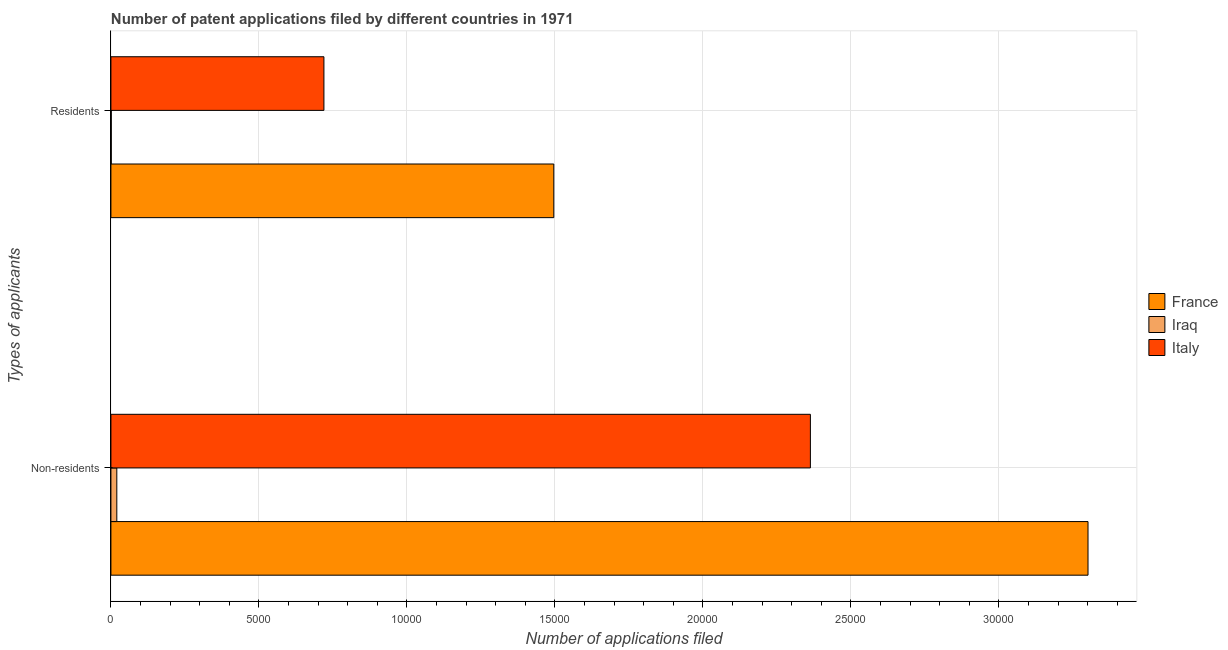What is the label of the 1st group of bars from the top?
Give a very brief answer. Residents. What is the number of patent applications by non residents in Iraq?
Provide a short and direct response. 199. Across all countries, what is the maximum number of patent applications by non residents?
Provide a succinct answer. 3.30e+04. Across all countries, what is the minimum number of patent applications by non residents?
Keep it short and to the point. 199. In which country was the number of patent applications by residents maximum?
Ensure brevity in your answer.  France. In which country was the number of patent applications by residents minimum?
Provide a short and direct response. Iraq. What is the total number of patent applications by non residents in the graph?
Provide a succinct answer. 5.68e+04. What is the difference between the number of patent applications by residents in Iraq and that in France?
Provide a short and direct response. -1.50e+04. What is the difference between the number of patent applications by residents in Italy and the number of patent applications by non residents in France?
Make the answer very short. -2.58e+04. What is the average number of patent applications by non residents per country?
Your response must be concise. 1.89e+04. What is the difference between the number of patent applications by non residents and number of patent applications by residents in Italy?
Make the answer very short. 1.64e+04. What is the ratio of the number of patent applications by non residents in Iraq to that in Italy?
Ensure brevity in your answer.  0.01. In how many countries, is the number of patent applications by residents greater than the average number of patent applications by residents taken over all countries?
Give a very brief answer. 1. What does the 2nd bar from the top in Residents represents?
Your answer should be compact. Iraq. Are all the bars in the graph horizontal?
Offer a terse response. Yes. How many countries are there in the graph?
Ensure brevity in your answer.  3. What is the difference between two consecutive major ticks on the X-axis?
Your response must be concise. 5000. Are the values on the major ticks of X-axis written in scientific E-notation?
Offer a very short reply. No. Does the graph contain any zero values?
Give a very brief answer. No. Does the graph contain grids?
Provide a short and direct response. Yes. How many legend labels are there?
Offer a very short reply. 3. What is the title of the graph?
Your answer should be compact. Number of patent applications filed by different countries in 1971. Does "Ethiopia" appear as one of the legend labels in the graph?
Your answer should be compact. No. What is the label or title of the X-axis?
Your answer should be compact. Number of applications filed. What is the label or title of the Y-axis?
Keep it short and to the point. Types of applicants. What is the Number of applications filed in France in Non-residents?
Offer a very short reply. 3.30e+04. What is the Number of applications filed of Iraq in Non-residents?
Offer a terse response. 199. What is the Number of applications filed of Italy in Non-residents?
Your answer should be very brief. 2.36e+04. What is the Number of applications filed in France in Residents?
Offer a terse response. 1.50e+04. What is the Number of applications filed of Italy in Residents?
Your response must be concise. 7196. Across all Types of applicants, what is the maximum Number of applications filed in France?
Your answer should be very brief. 3.30e+04. Across all Types of applicants, what is the maximum Number of applications filed in Iraq?
Provide a short and direct response. 199. Across all Types of applicants, what is the maximum Number of applications filed of Italy?
Make the answer very short. 2.36e+04. Across all Types of applicants, what is the minimum Number of applications filed in France?
Keep it short and to the point. 1.50e+04. Across all Types of applicants, what is the minimum Number of applications filed of Iraq?
Give a very brief answer. 12. Across all Types of applicants, what is the minimum Number of applications filed in Italy?
Make the answer very short. 7196. What is the total Number of applications filed in France in the graph?
Your answer should be compact. 4.80e+04. What is the total Number of applications filed of Iraq in the graph?
Your answer should be very brief. 211. What is the total Number of applications filed of Italy in the graph?
Provide a short and direct response. 3.08e+04. What is the difference between the Number of applications filed of France in Non-residents and that in Residents?
Make the answer very short. 1.80e+04. What is the difference between the Number of applications filed of Iraq in Non-residents and that in Residents?
Provide a succinct answer. 187. What is the difference between the Number of applications filed of Italy in Non-residents and that in Residents?
Provide a succinct answer. 1.64e+04. What is the difference between the Number of applications filed in France in Non-residents and the Number of applications filed in Iraq in Residents?
Your response must be concise. 3.30e+04. What is the difference between the Number of applications filed in France in Non-residents and the Number of applications filed in Italy in Residents?
Your answer should be very brief. 2.58e+04. What is the difference between the Number of applications filed of Iraq in Non-residents and the Number of applications filed of Italy in Residents?
Your answer should be very brief. -6997. What is the average Number of applications filed in France per Types of applicants?
Provide a short and direct response. 2.40e+04. What is the average Number of applications filed of Iraq per Types of applicants?
Provide a short and direct response. 105.5. What is the average Number of applications filed in Italy per Types of applicants?
Provide a short and direct response. 1.54e+04. What is the difference between the Number of applications filed in France and Number of applications filed in Iraq in Non-residents?
Offer a very short reply. 3.28e+04. What is the difference between the Number of applications filed of France and Number of applications filed of Italy in Non-residents?
Your answer should be very brief. 9379. What is the difference between the Number of applications filed in Iraq and Number of applications filed in Italy in Non-residents?
Offer a very short reply. -2.34e+04. What is the difference between the Number of applications filed in France and Number of applications filed in Iraq in Residents?
Your response must be concise. 1.50e+04. What is the difference between the Number of applications filed of France and Number of applications filed of Italy in Residents?
Your answer should be very brief. 7766. What is the difference between the Number of applications filed in Iraq and Number of applications filed in Italy in Residents?
Your answer should be very brief. -7184. What is the ratio of the Number of applications filed in France in Non-residents to that in Residents?
Offer a terse response. 2.21. What is the ratio of the Number of applications filed of Iraq in Non-residents to that in Residents?
Your response must be concise. 16.58. What is the ratio of the Number of applications filed in Italy in Non-residents to that in Residents?
Make the answer very short. 3.28. What is the difference between the highest and the second highest Number of applications filed in France?
Give a very brief answer. 1.80e+04. What is the difference between the highest and the second highest Number of applications filed of Iraq?
Offer a very short reply. 187. What is the difference between the highest and the second highest Number of applications filed in Italy?
Ensure brevity in your answer.  1.64e+04. What is the difference between the highest and the lowest Number of applications filed in France?
Ensure brevity in your answer.  1.80e+04. What is the difference between the highest and the lowest Number of applications filed in Iraq?
Provide a succinct answer. 187. What is the difference between the highest and the lowest Number of applications filed in Italy?
Your answer should be compact. 1.64e+04. 